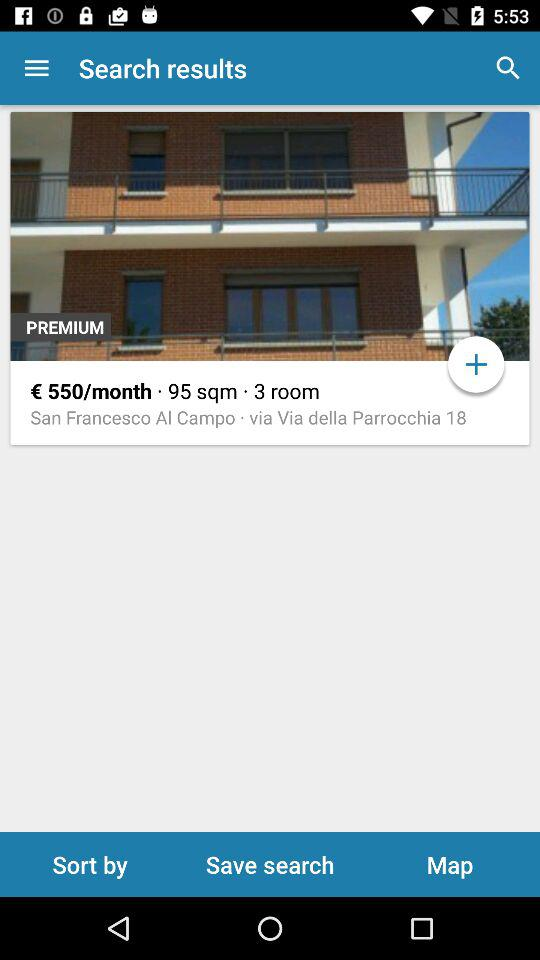What is the currency of the price? The currency of the price is the euro. 